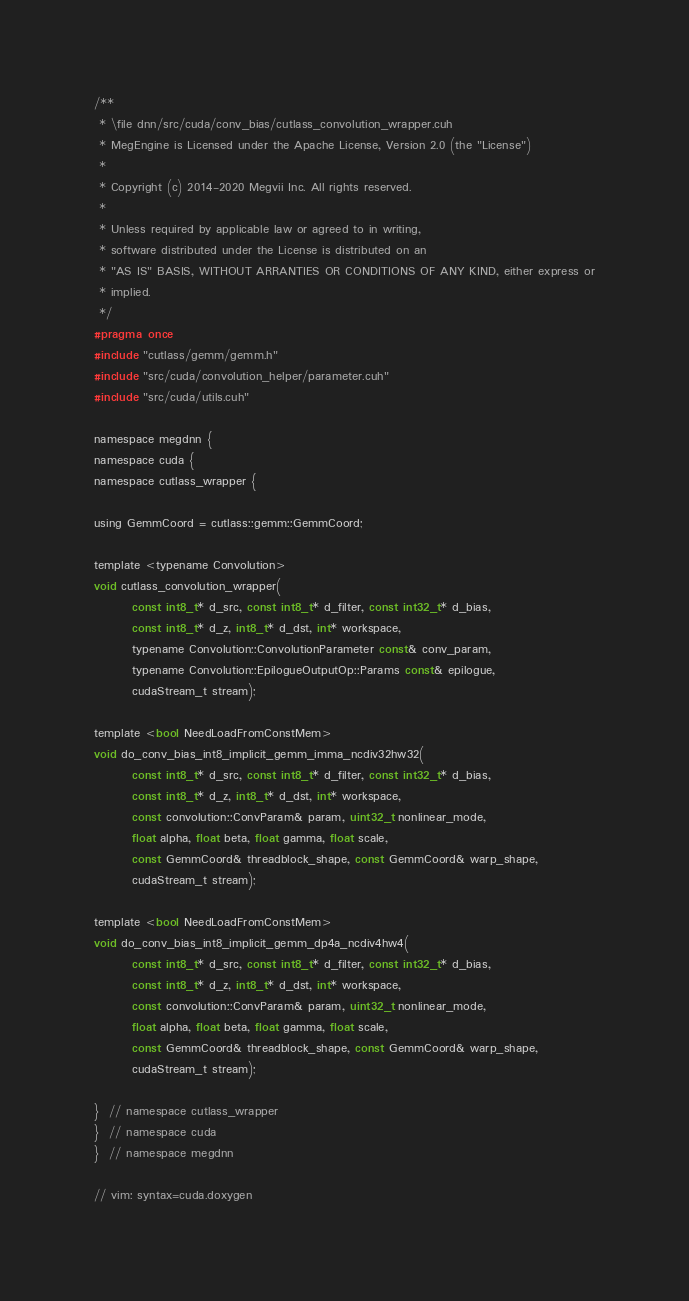<code> <loc_0><loc_0><loc_500><loc_500><_Cuda_>/**
 * \file dnn/src/cuda/conv_bias/cutlass_convolution_wrapper.cuh
 * MegEngine is Licensed under the Apache License, Version 2.0 (the "License")
 *
 * Copyright (c) 2014-2020 Megvii Inc. All rights reserved.
 *
 * Unless required by applicable law or agreed to in writing,
 * software distributed under the License is distributed on an
 * "AS IS" BASIS, WITHOUT ARRANTIES OR CONDITIONS OF ANY KIND, either express or
 * implied.
 */
#pragma once
#include "cutlass/gemm/gemm.h"
#include "src/cuda/convolution_helper/parameter.cuh"
#include "src/cuda/utils.cuh"

namespace megdnn {
namespace cuda {
namespace cutlass_wrapper {

using GemmCoord = cutlass::gemm::GemmCoord;

template <typename Convolution>
void cutlass_convolution_wrapper(
        const int8_t* d_src, const int8_t* d_filter, const int32_t* d_bias,
        const int8_t* d_z, int8_t* d_dst, int* workspace,
        typename Convolution::ConvolutionParameter const& conv_param,
        typename Convolution::EpilogueOutputOp::Params const& epilogue,
        cudaStream_t stream);

template <bool NeedLoadFromConstMem>
void do_conv_bias_int8_implicit_gemm_imma_ncdiv32hw32(
        const int8_t* d_src, const int8_t* d_filter, const int32_t* d_bias,
        const int8_t* d_z, int8_t* d_dst, int* workspace,
        const convolution::ConvParam& param, uint32_t nonlinear_mode,
        float alpha, float beta, float gamma, float scale,
        const GemmCoord& threadblock_shape, const GemmCoord& warp_shape,
        cudaStream_t stream);

template <bool NeedLoadFromConstMem>
void do_conv_bias_int8_implicit_gemm_dp4a_ncdiv4hw4(
        const int8_t* d_src, const int8_t* d_filter, const int32_t* d_bias,
        const int8_t* d_z, int8_t* d_dst, int* workspace,
        const convolution::ConvParam& param, uint32_t nonlinear_mode,
        float alpha, float beta, float gamma, float scale,
        const GemmCoord& threadblock_shape, const GemmCoord& warp_shape,
        cudaStream_t stream);

}  // namespace cutlass_wrapper
}  // namespace cuda
}  // namespace megdnn

// vim: syntax=cuda.doxygen
</code> 